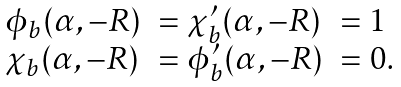<formula> <loc_0><loc_0><loc_500><loc_500>\begin{array} { l l l } \phi _ { b } ( \alpha , - R ) & = \chi ^ { \prime } _ { b } ( \alpha , - R ) & = 1 \\ \chi _ { b } ( \alpha , - R ) & = \phi ^ { \prime } _ { b } ( \alpha , - R ) & = 0 . \end{array}</formula> 